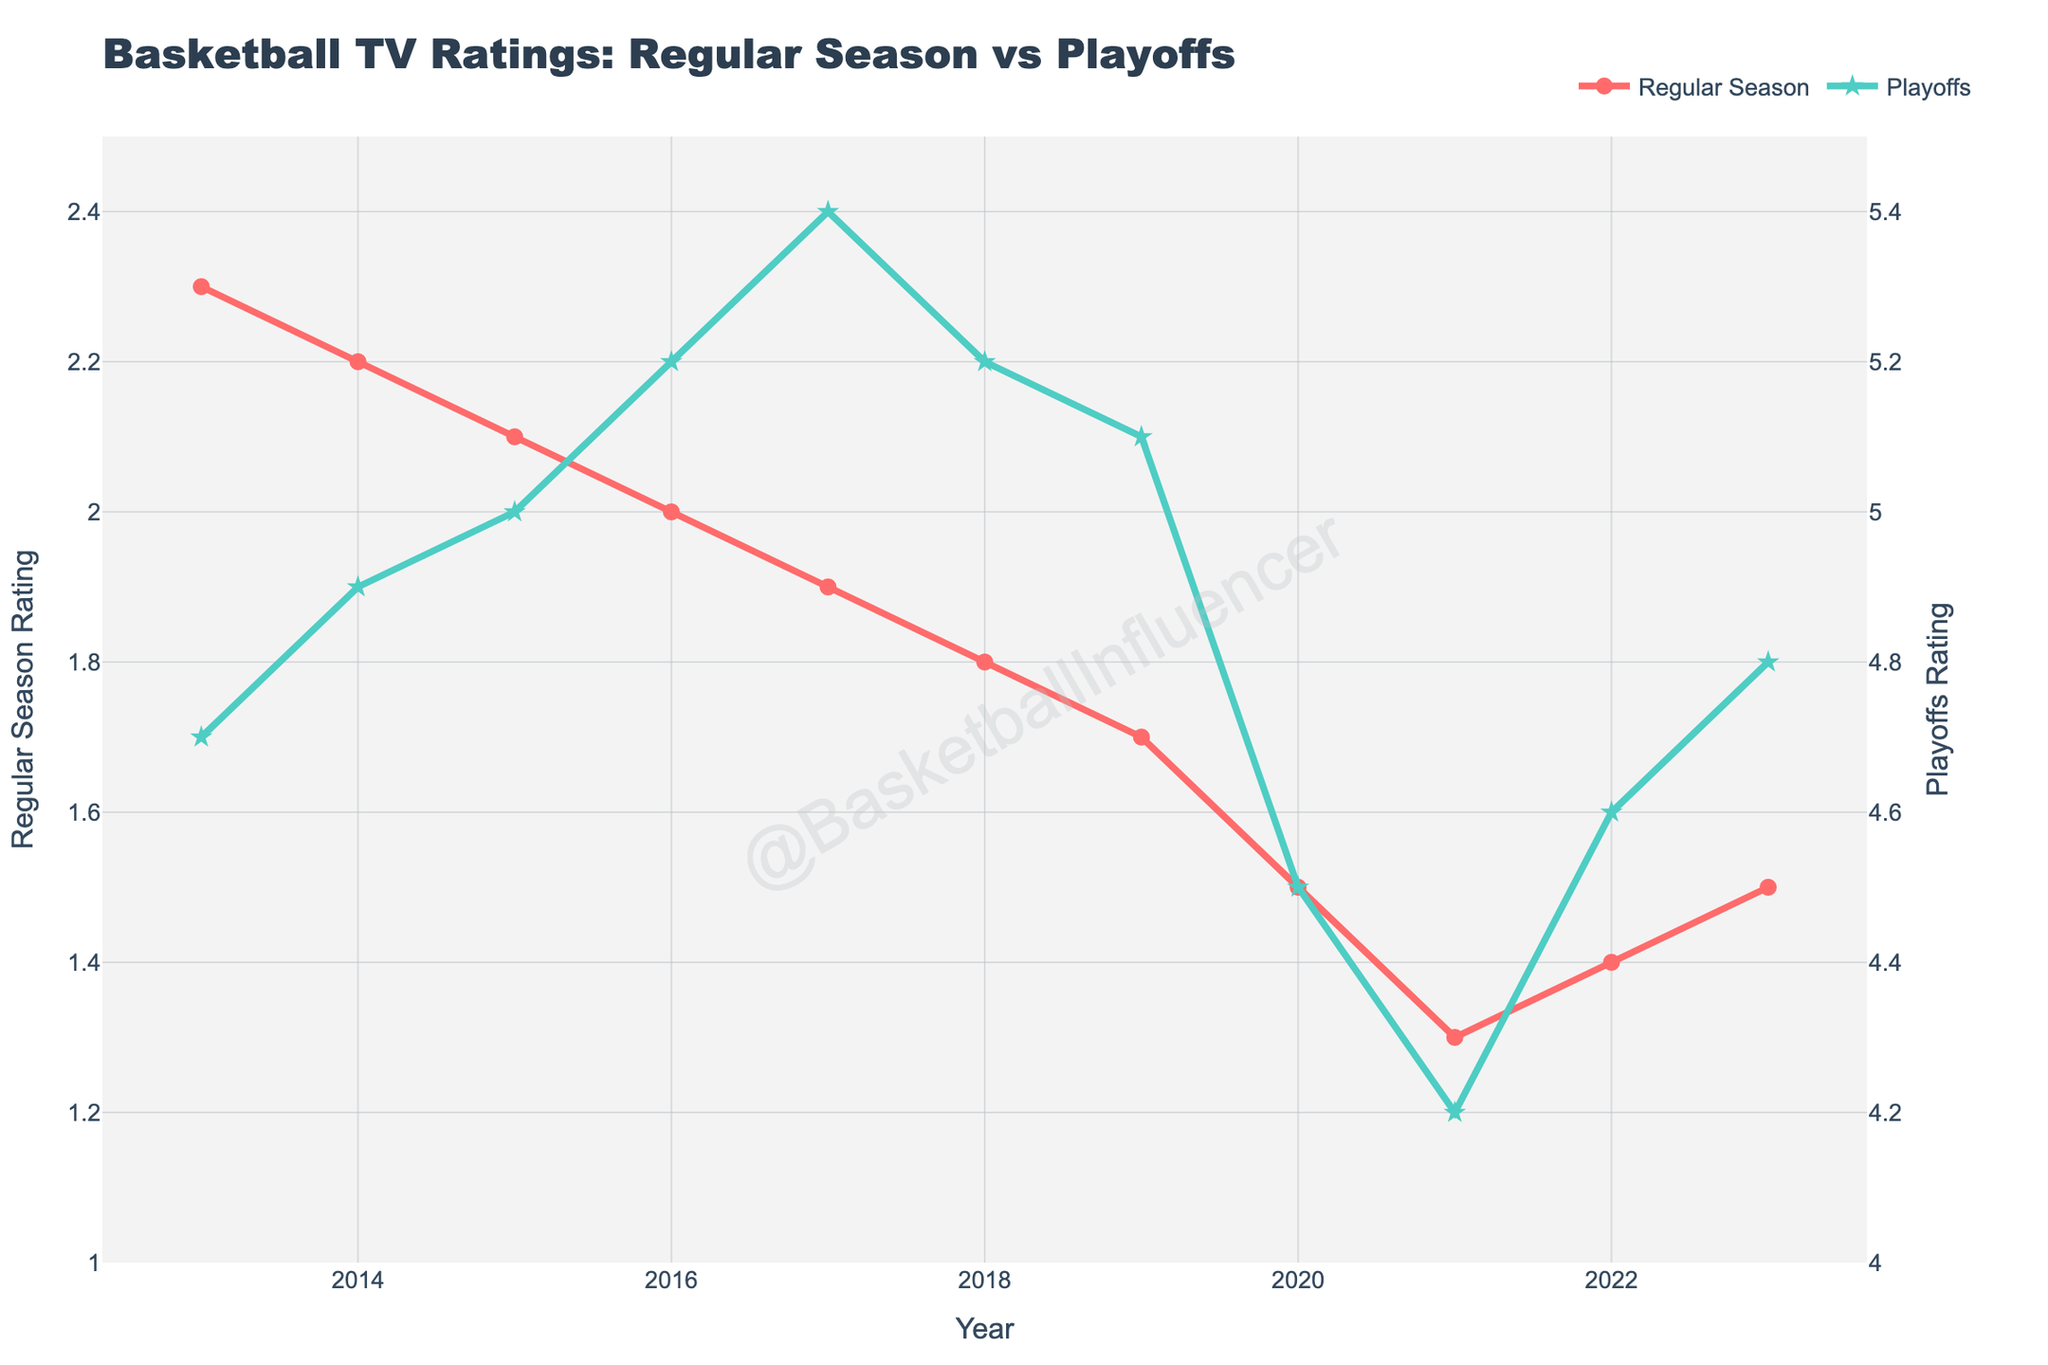What's the difference in the TV ratings between the Regular Season and Playoffs in 2015? The Regular Season rating in 2015 is 2.1, and the Playoffs rating in 2015 is 5.0. The difference is 5.0 - 2.1 = 2.9.
Answer: 2.9 How did the Regular Season ratings change from 2013 to 2023? The Regular Season ratings in 2013 are 2.3, and in 2023 they are 1.5. The change is 1.5 - 2.3 = -0.8.
Answer: -0.8 Which year had the highest Playoffs rating? By looking at the Playoffs ratings for all years, 2017 has the highest rating with a value of 5.4.
Answer: 2017 Did the Regular Season ratings ever drop below 1.5? By examining the Regular Season ratings from the figure, the lowest value is 1.3 in 2021.
Answer: Yes What was the general trend of Playoffs ratings from 2013 to 2023? By observing the Playoffs ratings over the years, they generally peaked around 2017 and slightly declined afterward until 2021, followed by a gradual increase again in 2023.
Answer: Declined after peaking around 2017, then slight increase Compare the Regular Season and Playoffs ratings in 2020. How much higher is one compared to the other? The Regular Season rating in 2020 is 1.5 and the Playoffs rating in 2020 is 4.5. The difference is 4.5 - 1.5 = 3.0.
Answer: 3.0 higher What is the average rating for the Playoffs over the decade? Sum of Playoffs ratings (4.7 + 4.9 + 5.0 + 5.2 + 5.4 + 5.2 + 5.1 + 4.5 + 4.2 + 4.6 + 4.8) = 53.6. There are 11 years, so the average is 53.6 / 11 ≈ 4.87.
Answer: 4.87 How did the Regular Season's rating in 2023 compare to its rating in 2019? The Regular Season rating in 2023 is 1.5 and in 2019, it is 1.7. The difference is 1.7 - 1.5 = 0.2, so the rating decreased by 0.2.
Answer: Decreased by 0.2 In which year did the Regular Season ratings drop the most compared to the previous year? The largest drop is from 2020 to 2021, where it decreased from 1.5 to 1.3, a difference of 0.2.
Answer: 2021 